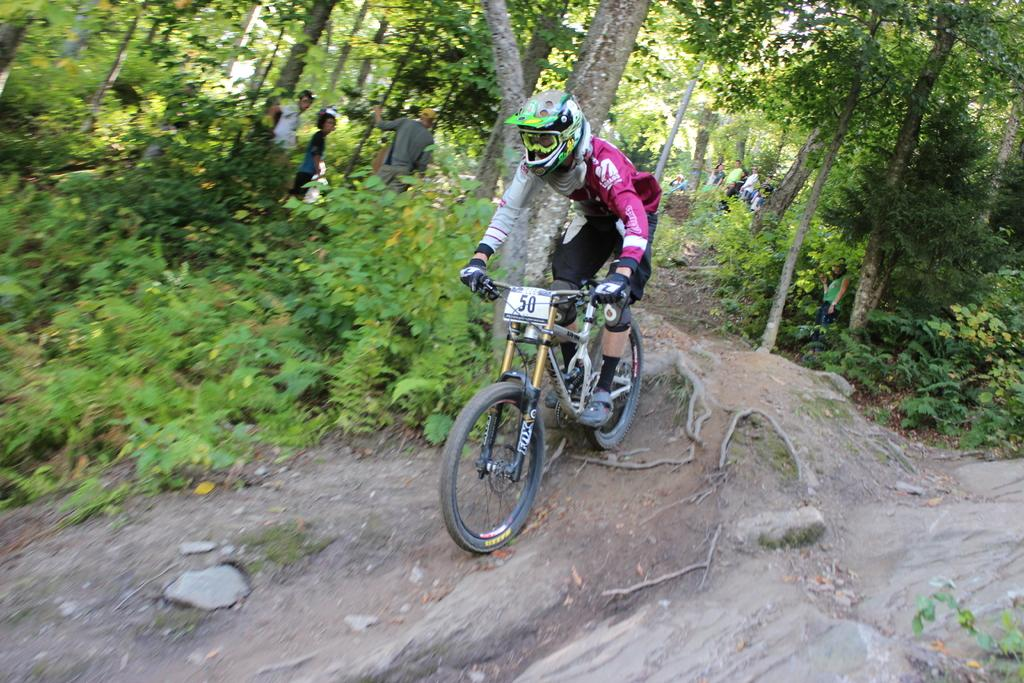What is the main subject of the image? There is a person riding a bicycle in the image. Are there any other people in the image? Yes, there is a group of people standing in the image. What can be seen in the background of the image? There are trees in the background of the image. What type of jewel is hanging from the bicycle in the image? There is no jewel hanging from the bicycle in the image. What is the air quality like in the image? The provided facts do not give any information about the air quality in the image. 